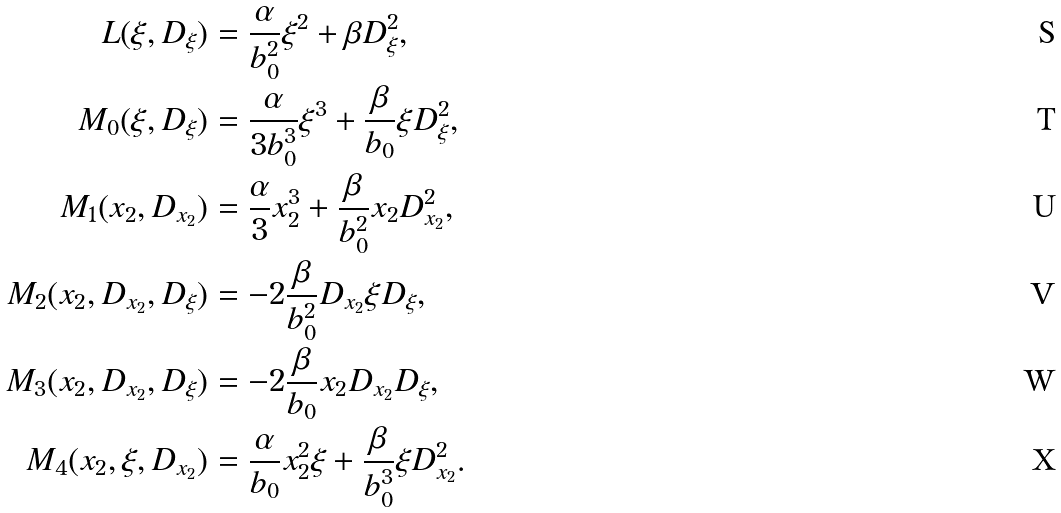Convert formula to latex. <formula><loc_0><loc_0><loc_500><loc_500>L ( \xi , D _ { \xi } ) & = \frac { \alpha } { b ^ { 2 } _ { 0 } } \xi ^ { 2 } + \beta D ^ { 2 } _ { \xi } , \\ M _ { 0 } ( \xi , D _ { \xi } ) & = \frac { \alpha } { 3 b ^ { 3 } _ { 0 } } \xi ^ { 3 } + \frac { \beta } { b _ { 0 } } \xi D ^ { 2 } _ { \xi } , \\ M _ { 1 } ( x _ { 2 } , D _ { x _ { 2 } } ) & = \frac { \alpha } { 3 } x _ { 2 } ^ { 3 } + \frac { \beta } { b _ { 0 } ^ { 2 } } x _ { 2 } D _ { x _ { 2 } } ^ { 2 } , \\ M _ { 2 } ( x _ { 2 } , D _ { x _ { 2 } } , D _ { \xi } ) & = - 2 \frac { \beta } { b _ { 0 } ^ { 2 } } D _ { x _ { 2 } } \xi D _ { \xi } , \\ M _ { 3 } ( x _ { 2 } , D _ { x _ { 2 } } , D _ { \xi } ) & = - 2 \frac { \beta } { b _ { 0 } } x _ { 2 } D _ { x _ { 2 } } D _ { \xi } , \\ M _ { 4 } ( x _ { 2 } , \xi , D _ { x _ { 2 } } ) & = \frac { \alpha } { b _ { 0 } } x ^ { 2 } _ { 2 } \xi + \frac { \beta } { b _ { 0 } ^ { 3 } } \xi D _ { x _ { 2 } } ^ { 2 } .</formula> 